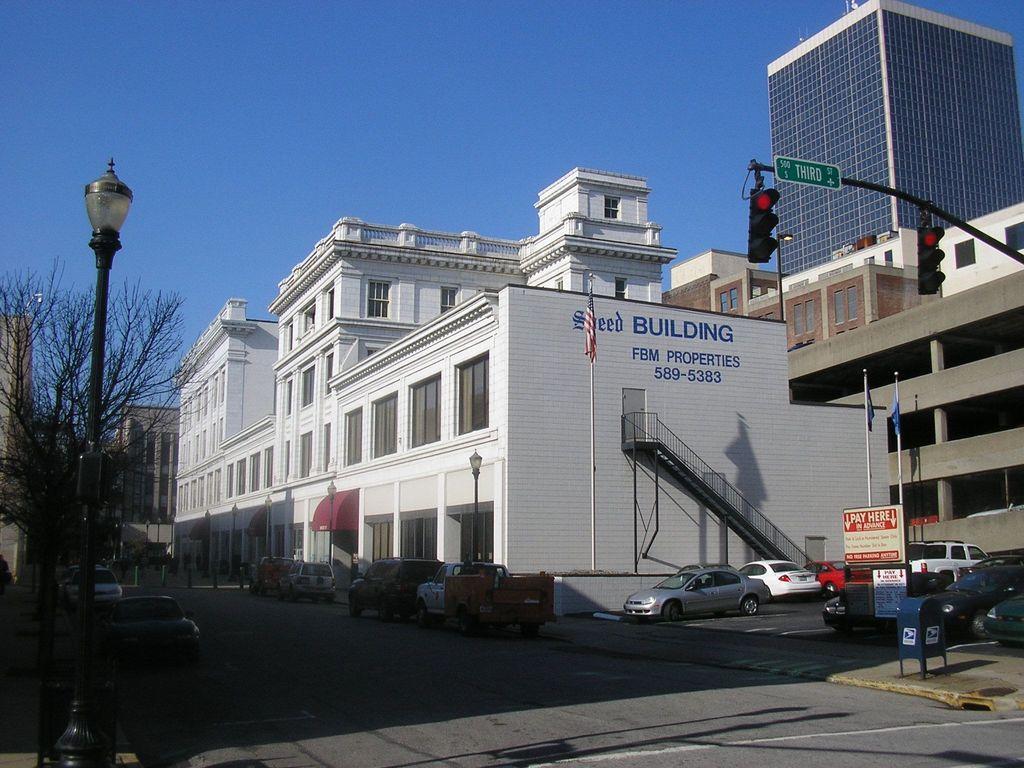In one or two sentences, can you explain what this image depicts? In this image, we can see the road, there are some cars, there are some buildings, on the right side, we can see stairs and railing, there is a flag, we can see the signal lights and a green sign board on the pole, on the left side, we can see a pole and a light on the pole, there is a tree, at the top we can see the blue sky. 